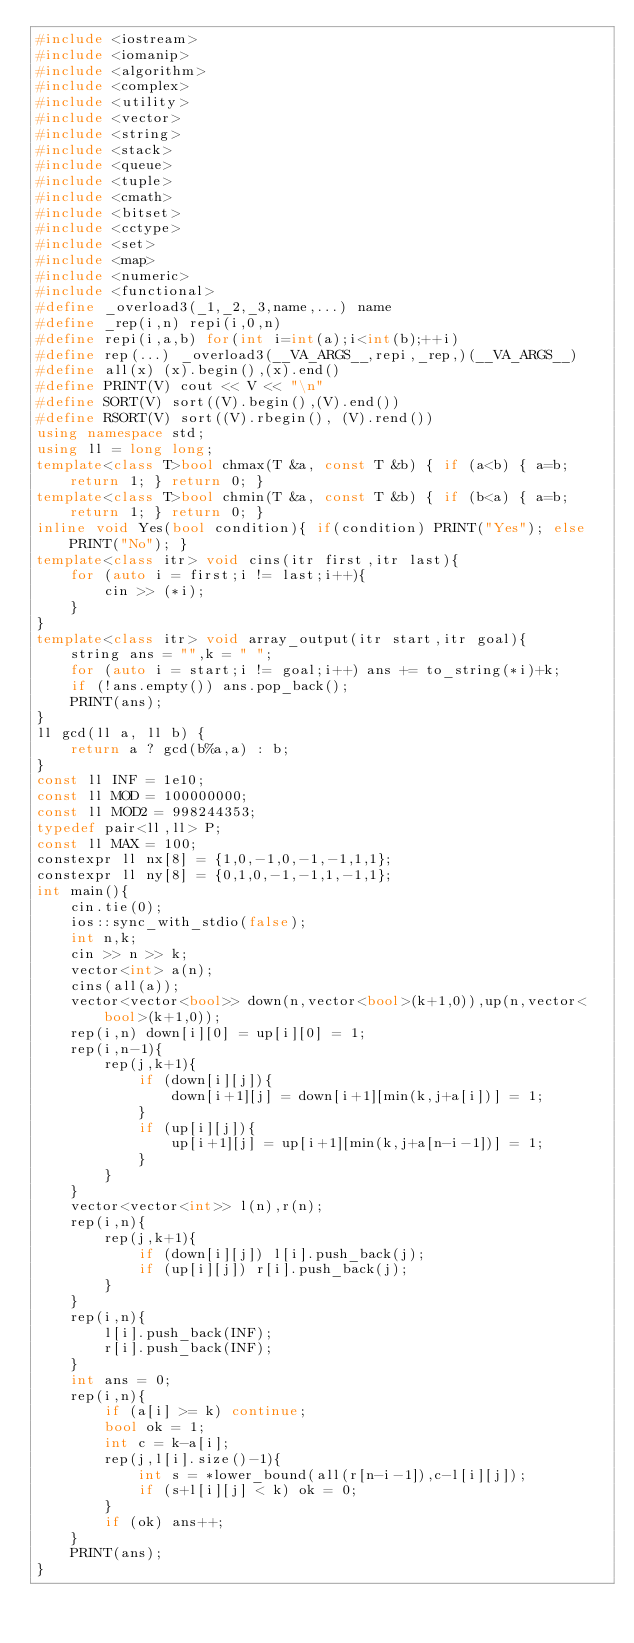Convert code to text. <code><loc_0><loc_0><loc_500><loc_500><_C++_>#include <iostream>
#include <iomanip>
#include <algorithm>
#include <complex>
#include <utility>
#include <vector>
#include <string>
#include <stack>
#include <queue>
#include <tuple>
#include <cmath>
#include <bitset>
#include <cctype>
#include <set>
#include <map>
#include <numeric>
#include <functional>
#define _overload3(_1,_2,_3,name,...) name
#define _rep(i,n) repi(i,0,n)
#define repi(i,a,b) for(int i=int(a);i<int(b);++i)
#define rep(...) _overload3(__VA_ARGS__,repi,_rep,)(__VA_ARGS__)
#define all(x) (x).begin(),(x).end()
#define PRINT(V) cout << V << "\n"
#define SORT(V) sort((V).begin(),(V).end())
#define RSORT(V) sort((V).rbegin(), (V).rend())
using namespace std;
using ll = long long;
template<class T>bool chmax(T &a, const T &b) { if (a<b) { a=b; return 1; } return 0; }
template<class T>bool chmin(T &a, const T &b) { if (b<a) { a=b; return 1; } return 0; }
inline void Yes(bool condition){ if(condition) PRINT("Yes"); else PRINT("No"); }
template<class itr> void cins(itr first,itr last){
    for (auto i = first;i != last;i++){
        cin >> (*i);
    }
}
template<class itr> void array_output(itr start,itr goal){
    string ans = "",k = " ";
    for (auto i = start;i != goal;i++) ans += to_string(*i)+k;
    if (!ans.empty()) ans.pop_back();
    PRINT(ans);
}
ll gcd(ll a, ll b) {
    return a ? gcd(b%a,a) : b;
}
const ll INF = 1e10;
const ll MOD = 100000000;
const ll MOD2 = 998244353;
typedef pair<ll,ll> P;
const ll MAX = 100;
constexpr ll nx[8] = {1,0,-1,0,-1,-1,1,1};
constexpr ll ny[8] = {0,1,0,-1,-1,1,-1,1};
int main(){
    cin.tie(0);
    ios::sync_with_stdio(false);
    int n,k;
    cin >> n >> k;
    vector<int> a(n);
    cins(all(a));
    vector<vector<bool>> down(n,vector<bool>(k+1,0)),up(n,vector<bool>(k+1,0));
    rep(i,n) down[i][0] = up[i][0] = 1;
    rep(i,n-1){
        rep(j,k+1){
            if (down[i][j]){
                down[i+1][j] = down[i+1][min(k,j+a[i])] = 1;
            }
            if (up[i][j]){
                up[i+1][j] = up[i+1][min(k,j+a[n-i-1])] = 1;
            }
        }
    }
    vector<vector<int>> l(n),r(n);
    rep(i,n){
        rep(j,k+1){
            if (down[i][j]) l[i].push_back(j);
            if (up[i][j]) r[i].push_back(j);
        }
    }
    rep(i,n){
        l[i].push_back(INF);
        r[i].push_back(INF);
    }
    int ans = 0;
    rep(i,n){
        if (a[i] >= k) continue;
        bool ok = 1;
        int c = k-a[i];
        rep(j,l[i].size()-1){
            int s = *lower_bound(all(r[n-i-1]),c-l[i][j]);
            if (s+l[i][j] < k) ok = 0;
        }
        if (ok) ans++;
    }
    PRINT(ans);
}
</code> 